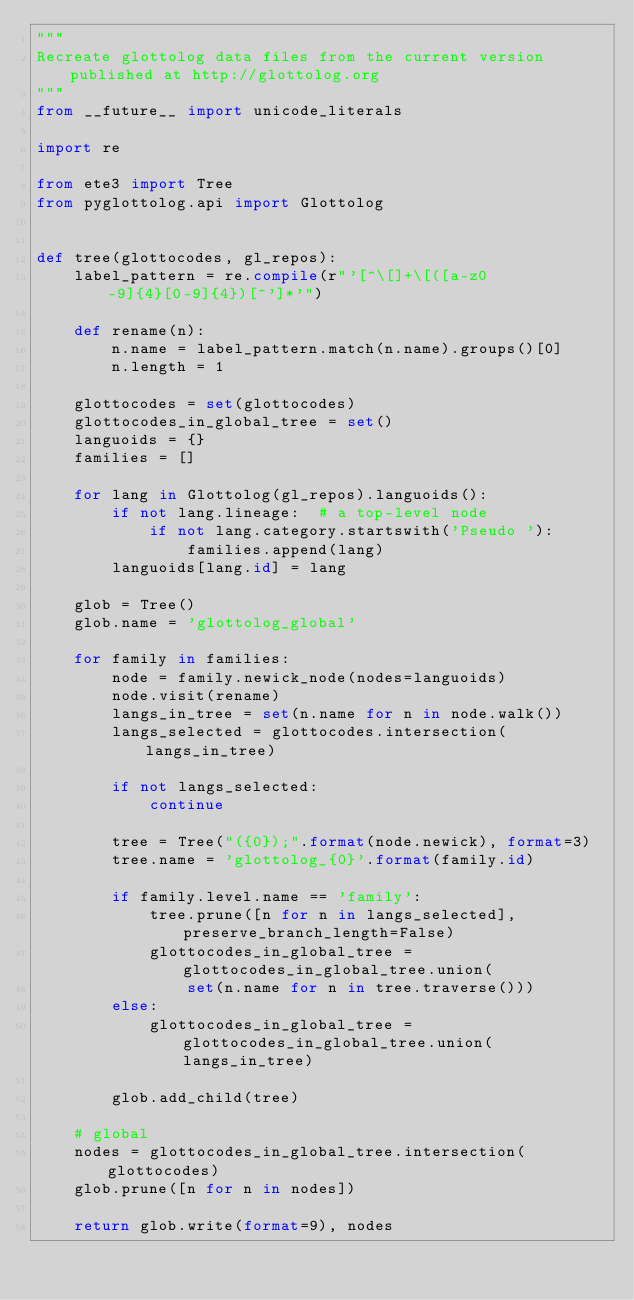<code> <loc_0><loc_0><loc_500><loc_500><_Python_>"""
Recreate glottolog data files from the current version published at http://glottolog.org
"""
from __future__ import unicode_literals

import re

from ete3 import Tree
from pyglottolog.api import Glottolog


def tree(glottocodes, gl_repos):
    label_pattern = re.compile(r"'[^\[]+\[([a-z0-9]{4}[0-9]{4})[^']*'")

    def rename(n):
        n.name = label_pattern.match(n.name).groups()[0]
        n.length = 1

    glottocodes = set(glottocodes)
    glottocodes_in_global_tree = set()
    languoids = {}
    families = []

    for lang in Glottolog(gl_repos).languoids():
        if not lang.lineage:  # a top-level node
            if not lang.category.startswith('Pseudo '):
                families.append(lang)
        languoids[lang.id] = lang

    glob = Tree()
    glob.name = 'glottolog_global'

    for family in families:
        node = family.newick_node(nodes=languoids)
        node.visit(rename)
        langs_in_tree = set(n.name for n in node.walk())
        langs_selected = glottocodes.intersection(langs_in_tree)

        if not langs_selected:
            continue

        tree = Tree("({0});".format(node.newick), format=3)
        tree.name = 'glottolog_{0}'.format(family.id)

        if family.level.name == 'family':
            tree.prune([n for n in langs_selected], preserve_branch_length=False)
            glottocodes_in_global_tree = glottocodes_in_global_tree.union(
                set(n.name for n in tree.traverse()))
        else:
            glottocodes_in_global_tree = glottocodes_in_global_tree.union(langs_in_tree)

        glob.add_child(tree)

    # global
    nodes = glottocodes_in_global_tree.intersection(glottocodes)
    glob.prune([n for n in nodes])

    return glob.write(format=9), nodes
</code> 